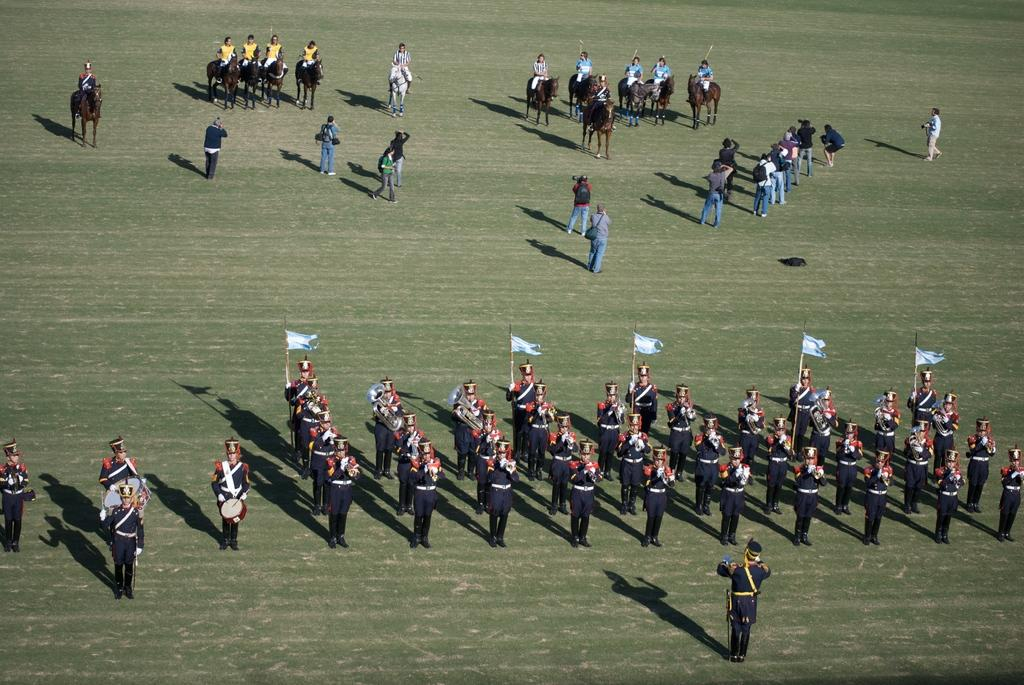Who or what can be seen in the image? There are people in the image. What else is present in the image besides people? There are flags in the image. Can you describe the people in the image? Some of the people are sitting on horses in the image. What type of hook can be seen attached to the boat in the image? There is no boat or hook present in the image. What part of the horse is being used to hold the part in the image? There is no part being held by the horse in the image; the people are sitting on the horses. 